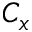<formula> <loc_0><loc_0><loc_500><loc_500>C _ { x }</formula> 